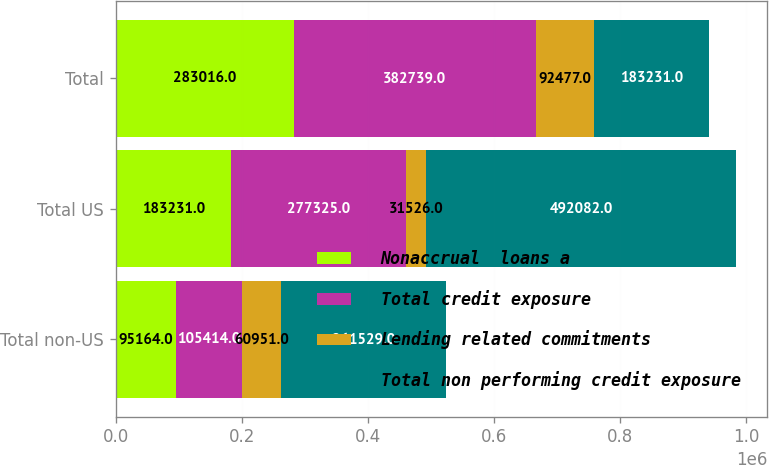Convert chart. <chart><loc_0><loc_0><loc_500><loc_500><stacked_bar_chart><ecel><fcel>Total non-US<fcel>Total US<fcel>Total<nl><fcel>Nonaccrual  loans a<fcel>95164<fcel>183231<fcel>283016<nl><fcel>Total credit exposure<fcel>105414<fcel>277325<fcel>382739<nl><fcel>Lending related commitments<fcel>60951<fcel>31526<fcel>92477<nl><fcel>Total non performing credit exposure<fcel>261529<fcel>492082<fcel>183231<nl></chart> 